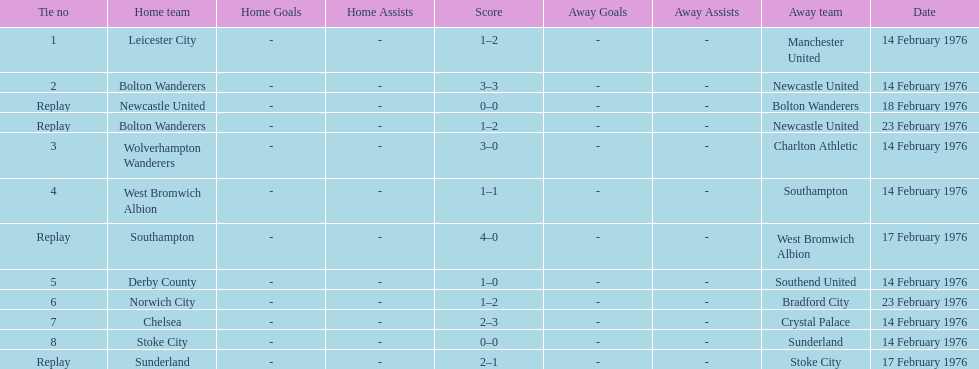How many of these games occurred before 17 february 1976? 7. 